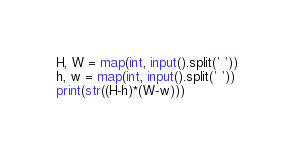<code> <loc_0><loc_0><loc_500><loc_500><_Python_>H, W = map(int, input().split(' '))
h, w = map(int, input().split(' '))
print(str((H-h)*(W-w)))</code> 